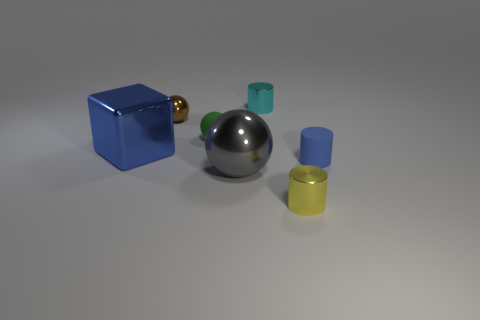Subtract all tiny cyan metal cylinders. How many cylinders are left? 2 Add 1 blue cylinders. How many objects exist? 8 Subtract all cyan balls. Subtract all purple cylinders. How many balls are left? 3 Subtract all small blue matte cylinders. Subtract all tiny shiny spheres. How many objects are left? 5 Add 4 cylinders. How many cylinders are left? 7 Add 4 tiny blue rubber cylinders. How many tiny blue rubber cylinders exist? 5 Subtract 1 gray balls. How many objects are left? 6 Subtract all cubes. How many objects are left? 6 